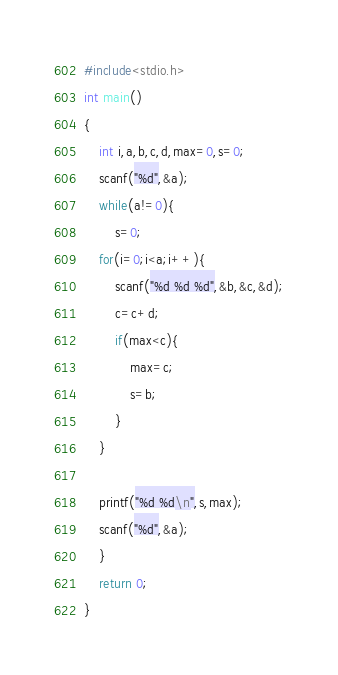<code> <loc_0><loc_0><loc_500><loc_500><_C_>#include<stdio.h>
int main()
{
	int i,a,b,c,d,max=0,s=0;
	scanf("%d",&a);
	while(a!=0){
		s=0;
	for(i=0;i<a;i++){
		scanf("%d %d %d",&b,&c,&d);
		c=c+d;
		if(max<c){
			max=c;
			s=b;
		}
	}
	
	printf("%d %d\n",s,max);
	scanf("%d",&a);
	}
	return 0;
}</code> 